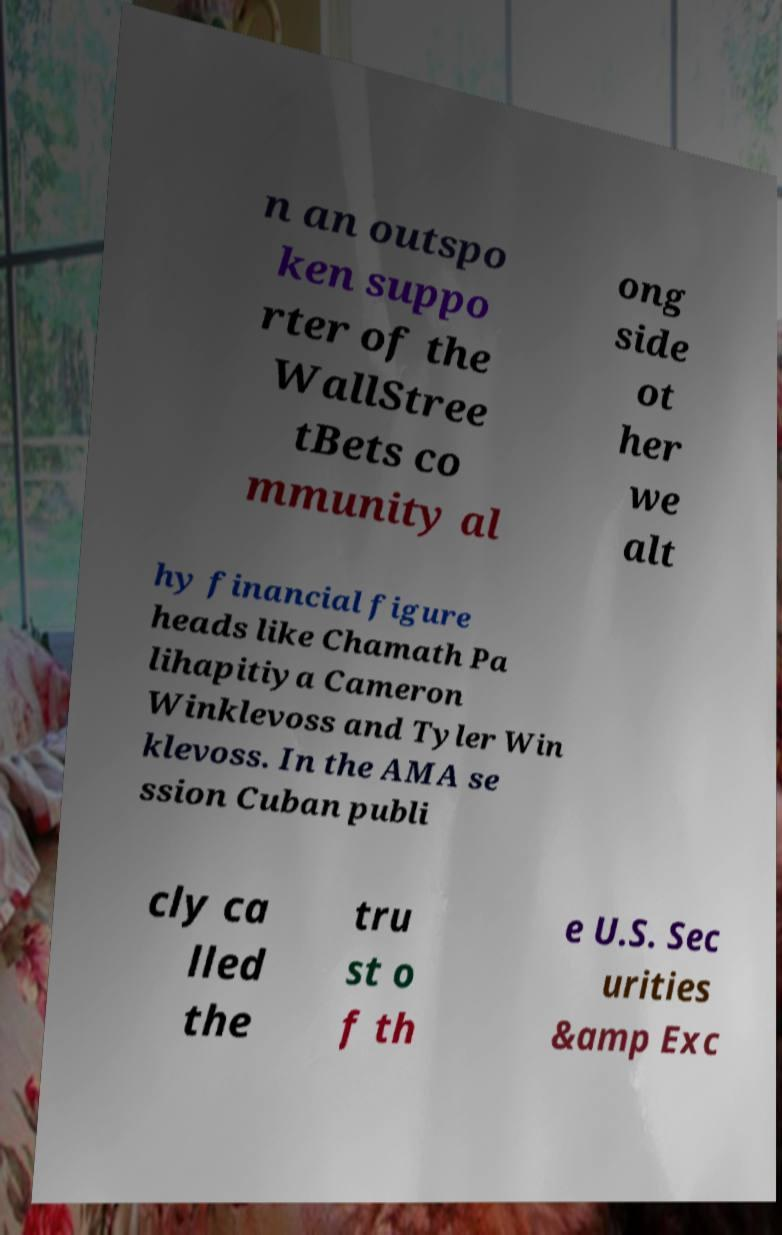Can you read and provide the text displayed in the image?This photo seems to have some interesting text. Can you extract and type it out for me? n an outspo ken suppo rter of the WallStree tBets co mmunity al ong side ot her we alt hy financial figure heads like Chamath Pa lihapitiya Cameron Winklevoss and Tyler Win klevoss. In the AMA se ssion Cuban publi cly ca lled the tru st o f th e U.S. Sec urities &amp Exc 